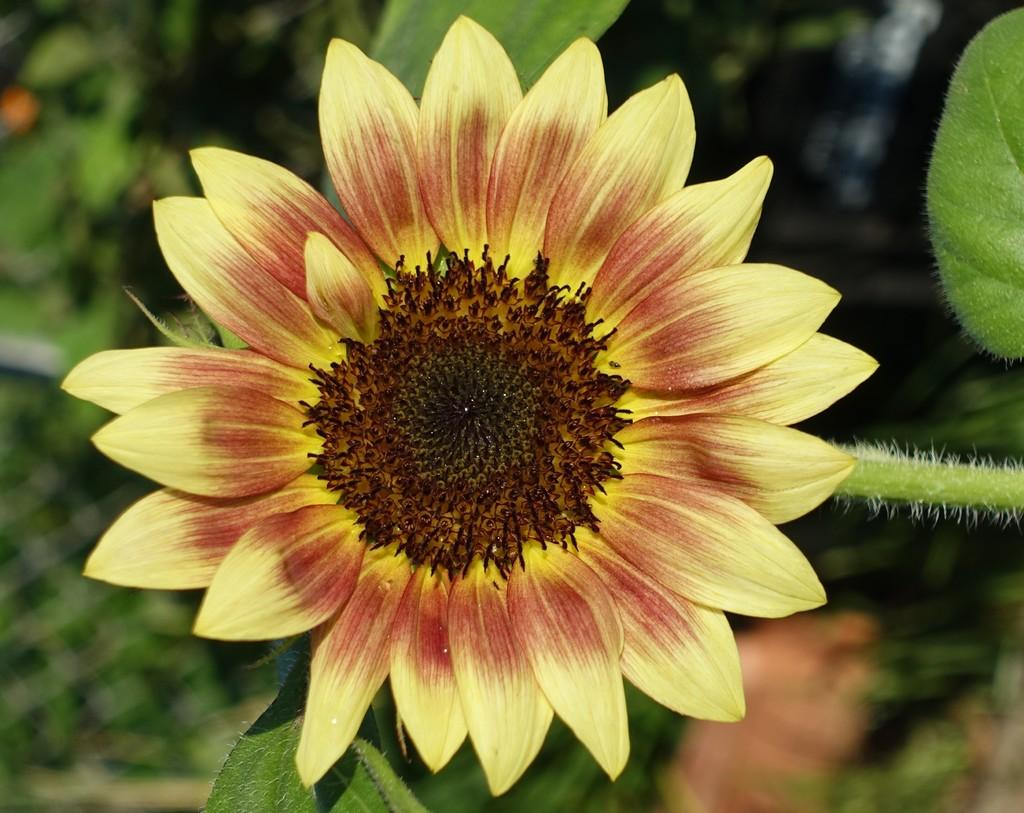Where was the image taken? The image was taken outdoors. What can be seen in the background of the image? There are plants in the background of the image. What type of plant is the main focus of the image? There is a plant with a sunflower in the middle of the image. What type of fiction is the maid reading in the image? There is no maid or any reading material present in the image. 